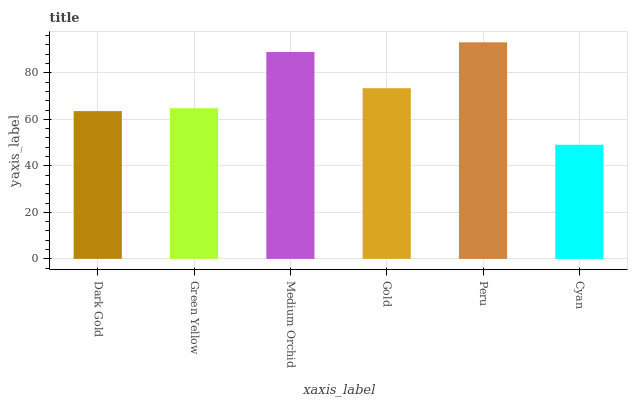Is Cyan the minimum?
Answer yes or no. Yes. Is Peru the maximum?
Answer yes or no. Yes. Is Green Yellow the minimum?
Answer yes or no. No. Is Green Yellow the maximum?
Answer yes or no. No. Is Green Yellow greater than Dark Gold?
Answer yes or no. Yes. Is Dark Gold less than Green Yellow?
Answer yes or no. Yes. Is Dark Gold greater than Green Yellow?
Answer yes or no. No. Is Green Yellow less than Dark Gold?
Answer yes or no. No. Is Gold the high median?
Answer yes or no. Yes. Is Green Yellow the low median?
Answer yes or no. Yes. Is Medium Orchid the high median?
Answer yes or no. No. Is Gold the low median?
Answer yes or no. No. 